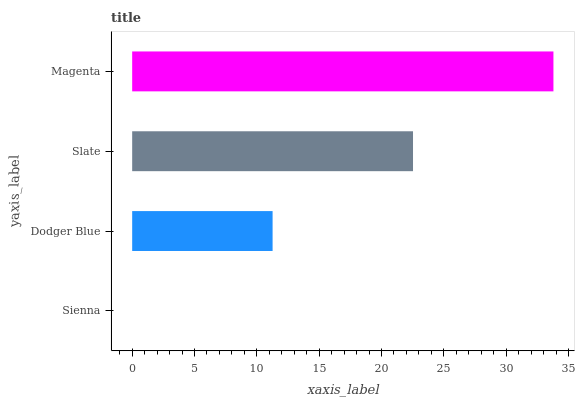Is Sienna the minimum?
Answer yes or no. Yes. Is Magenta the maximum?
Answer yes or no. Yes. Is Dodger Blue the minimum?
Answer yes or no. No. Is Dodger Blue the maximum?
Answer yes or no. No. Is Dodger Blue greater than Sienna?
Answer yes or no. Yes. Is Sienna less than Dodger Blue?
Answer yes or no. Yes. Is Sienna greater than Dodger Blue?
Answer yes or no. No. Is Dodger Blue less than Sienna?
Answer yes or no. No. Is Slate the high median?
Answer yes or no. Yes. Is Dodger Blue the low median?
Answer yes or no. Yes. Is Magenta the high median?
Answer yes or no. No. Is Sienna the low median?
Answer yes or no. No. 